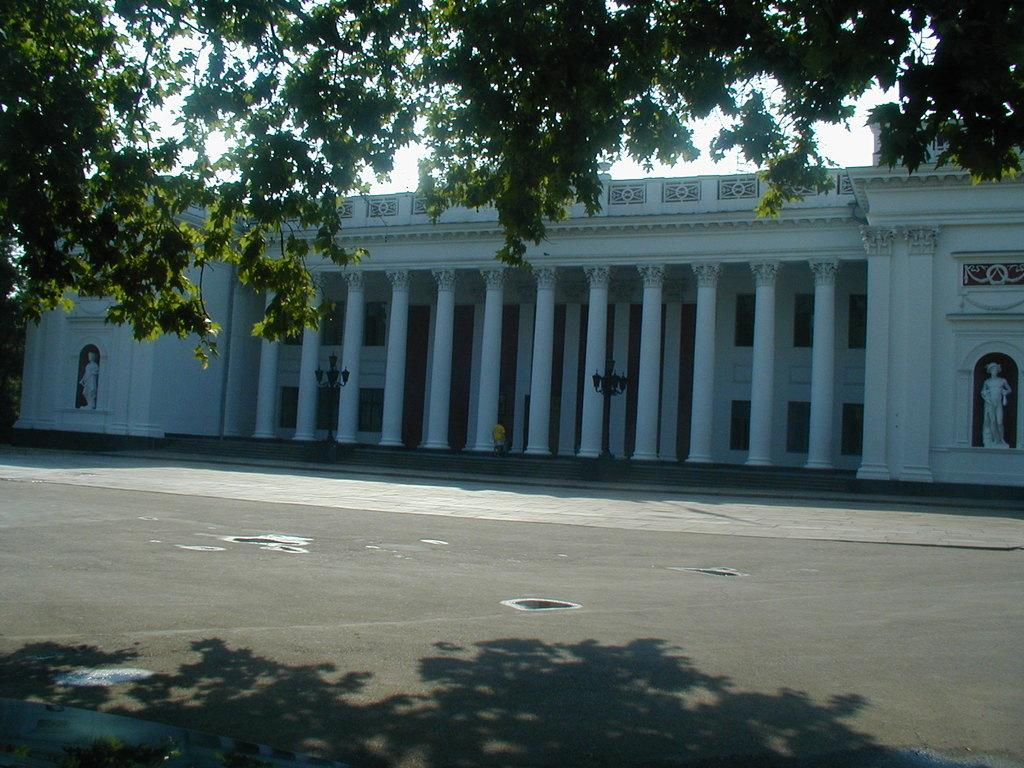What type of surface is visible in the image? There is a pavement in the image. What can be seen in the distance behind the pavement? There is a building in the background of the image. What type of vegetation is visible at the top of the image? There are trees visible at the top of the image. What type of fruit is hanging from the trees in the image? There is no fruit visible in the image; only trees are present. What is the wrist of the person in the image doing? There is no person present in the image, so it is not possible to determine what their wrist is doing. 